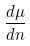<formula> <loc_0><loc_0><loc_500><loc_500>\frac { d \mu } { d n }</formula> 